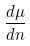<formula> <loc_0><loc_0><loc_500><loc_500>\frac { d \mu } { d n }</formula> 